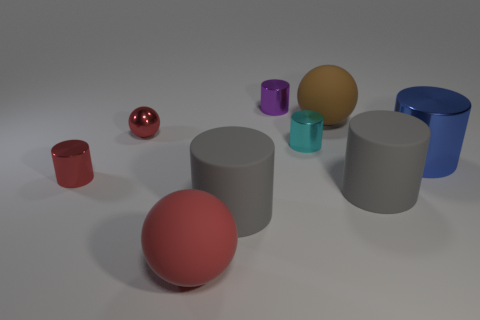Subtract all large gray rubber cylinders. How many cylinders are left? 4 Subtract all blue cylinders. How many cylinders are left? 5 Subtract all purple cylinders. Subtract all red spheres. How many cylinders are left? 5 Add 1 cyan objects. How many objects exist? 10 Subtract all cylinders. How many objects are left? 3 Subtract 0 green blocks. How many objects are left? 9 Subtract all small red objects. Subtract all big metal objects. How many objects are left? 6 Add 7 big brown rubber things. How many big brown rubber things are left? 8 Add 6 large brown balls. How many large brown balls exist? 7 